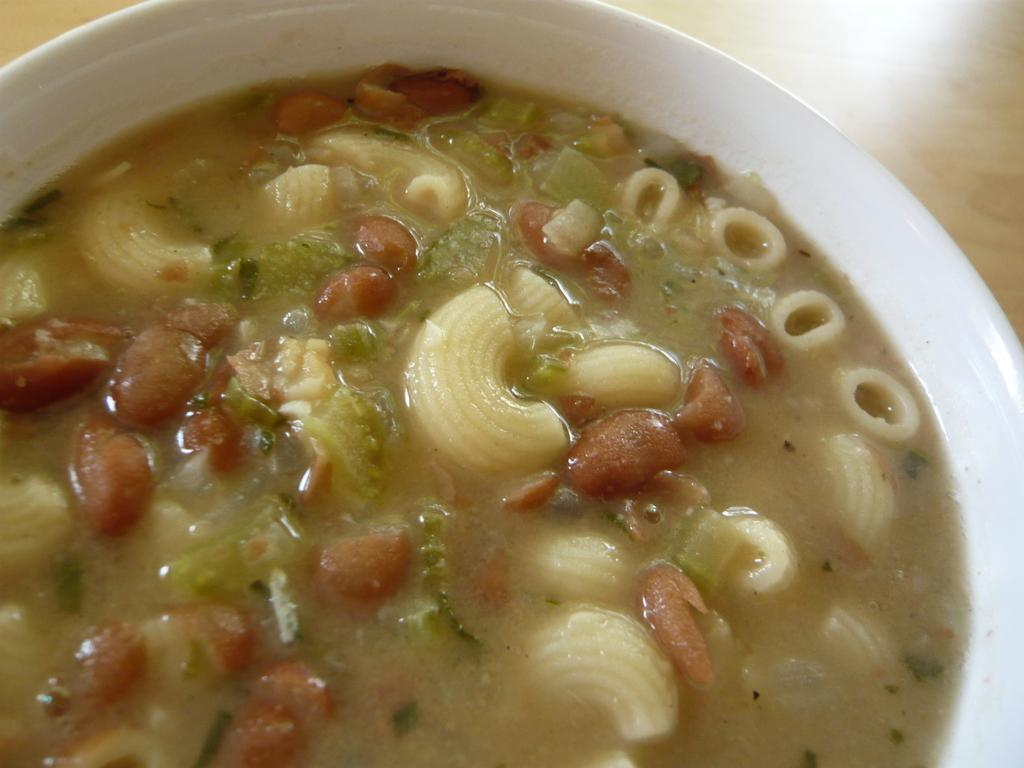What type of food can be seen in the image? The food in the image has yellow and red colors. What color is the bowl that contains the food? The bowl is white. On what surface is the bowl placed? The bowl is placed on a brown color table. What activity is the mother doing with the cook in the image? There is no mother or cook present in the image; it only features food in a bowl on a table. 